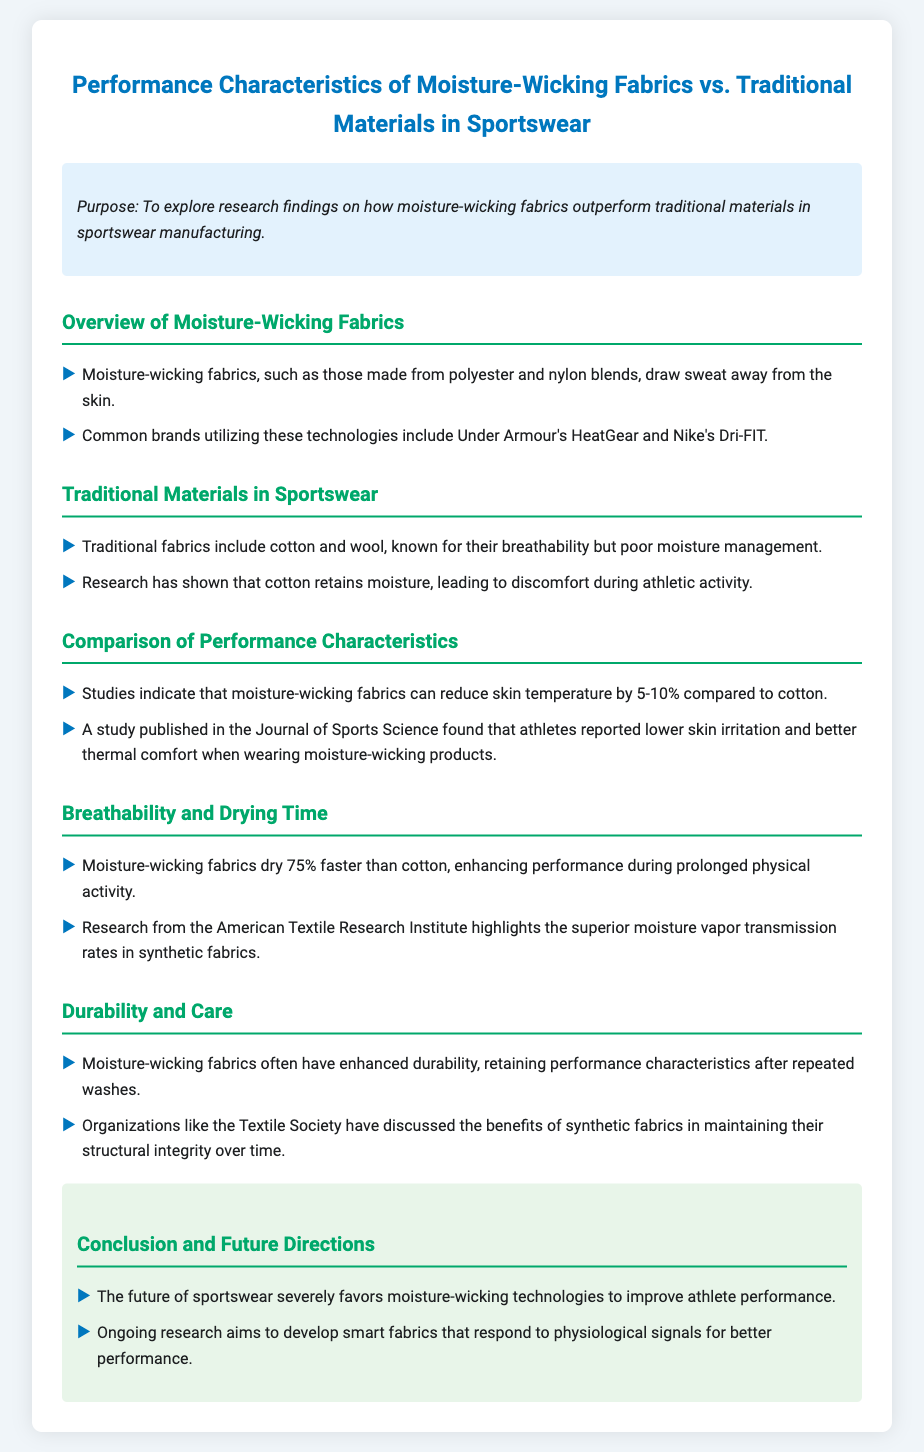What are moisture-wicking fabrics made from? Moisture-wicking fabrics are made from polyester and nylon blends.
Answer: polyester and nylon blends Which brands utilize moisture-wicking technologies? Common brands include Under Armour and Nike.
Answer: Under Armour and Nike How much faster do moisture-wicking fabrics dry compared to cotton? Moisture-wicking fabrics dry 75% faster than cotton.
Answer: 75% What is the reported skin temperature reduction when using moisture-wicking fabrics? Moisture-wicking fabrics can reduce skin temperature by 5-10%.
Answer: 5-10% What type of research has highlighted superior moisture vapor transmission rates? Research from the American Textile Research Institute highlights this.
Answer: American Textile Research Institute What is the impact of moisture-wicking fabrics on skin irritation? Athletes reported lower skin irritation when wearing moisture-wicking products.
Answer: lower skin irritation What structural benefit do moisture-wicking fabrics have after washing? They retain performance characteristics after repeated washes.
Answer: retain performance characteristics What future direction is mentioned for sportswear technology? Ongoing research aims to develop smart fabrics.
Answer: smart fabrics 